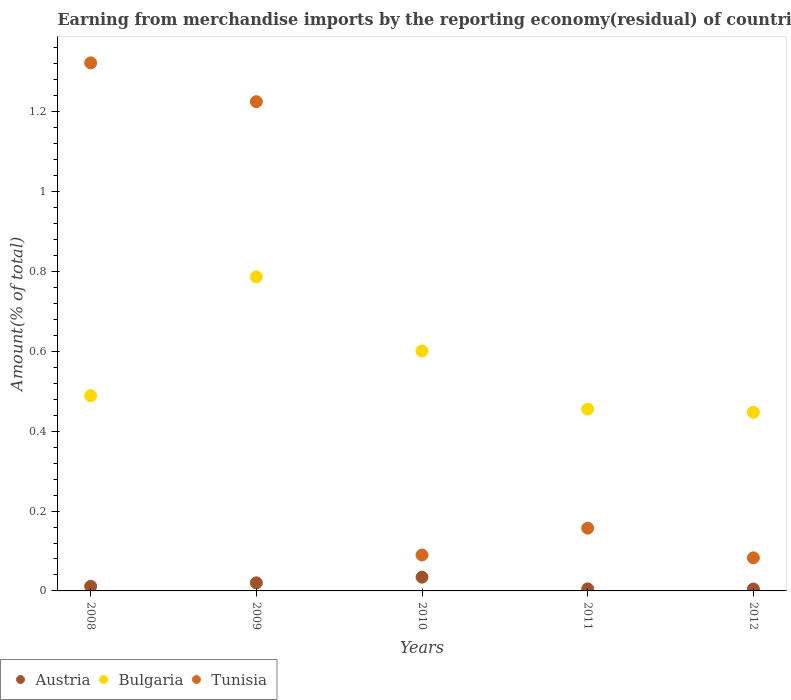Is the number of dotlines equal to the number of legend labels?
Your answer should be compact. Yes. What is the percentage of amount earned from merchandise imports in Bulgaria in 2008?
Offer a terse response. 0.49. Across all years, what is the maximum percentage of amount earned from merchandise imports in Bulgaria?
Offer a terse response. 0.79. Across all years, what is the minimum percentage of amount earned from merchandise imports in Tunisia?
Your response must be concise. 0.08. In which year was the percentage of amount earned from merchandise imports in Austria maximum?
Keep it short and to the point. 2010. In which year was the percentage of amount earned from merchandise imports in Tunisia minimum?
Give a very brief answer. 2012. What is the total percentage of amount earned from merchandise imports in Tunisia in the graph?
Provide a succinct answer. 2.88. What is the difference between the percentage of amount earned from merchandise imports in Tunisia in 2008 and that in 2012?
Your response must be concise. 1.24. What is the difference between the percentage of amount earned from merchandise imports in Bulgaria in 2009 and the percentage of amount earned from merchandise imports in Tunisia in 2008?
Provide a short and direct response. -0.54. What is the average percentage of amount earned from merchandise imports in Bulgaria per year?
Ensure brevity in your answer.  0.56. In the year 2009, what is the difference between the percentage of amount earned from merchandise imports in Tunisia and percentage of amount earned from merchandise imports in Austria?
Provide a short and direct response. 1.21. What is the ratio of the percentage of amount earned from merchandise imports in Tunisia in 2010 to that in 2012?
Give a very brief answer. 1.09. What is the difference between the highest and the second highest percentage of amount earned from merchandise imports in Tunisia?
Your response must be concise. 0.1. What is the difference between the highest and the lowest percentage of amount earned from merchandise imports in Austria?
Your answer should be very brief. 0.03. In how many years, is the percentage of amount earned from merchandise imports in Austria greater than the average percentage of amount earned from merchandise imports in Austria taken over all years?
Your answer should be very brief. 2. Is the sum of the percentage of amount earned from merchandise imports in Bulgaria in 2011 and 2012 greater than the maximum percentage of amount earned from merchandise imports in Austria across all years?
Your response must be concise. Yes. Is it the case that in every year, the sum of the percentage of amount earned from merchandise imports in Tunisia and percentage of amount earned from merchandise imports in Austria  is greater than the percentage of amount earned from merchandise imports in Bulgaria?
Ensure brevity in your answer.  No. Does the percentage of amount earned from merchandise imports in Austria monotonically increase over the years?
Ensure brevity in your answer.  No. Is the percentage of amount earned from merchandise imports in Bulgaria strictly less than the percentage of amount earned from merchandise imports in Austria over the years?
Your answer should be compact. No. How many dotlines are there?
Your answer should be compact. 3. How many years are there in the graph?
Make the answer very short. 5. What is the difference between two consecutive major ticks on the Y-axis?
Offer a very short reply. 0.2. Where does the legend appear in the graph?
Provide a succinct answer. Bottom left. What is the title of the graph?
Keep it short and to the point. Earning from merchandise imports by the reporting economy(residual) of countries. Does "Central Europe" appear as one of the legend labels in the graph?
Offer a very short reply. No. What is the label or title of the Y-axis?
Offer a terse response. Amount(% of total). What is the Amount(% of total) in Austria in 2008?
Your answer should be very brief. 0.01. What is the Amount(% of total) of Bulgaria in 2008?
Make the answer very short. 0.49. What is the Amount(% of total) in Tunisia in 2008?
Your answer should be very brief. 1.32. What is the Amount(% of total) of Austria in 2009?
Your answer should be compact. 0.02. What is the Amount(% of total) in Bulgaria in 2009?
Offer a very short reply. 0.79. What is the Amount(% of total) of Tunisia in 2009?
Make the answer very short. 1.23. What is the Amount(% of total) in Austria in 2010?
Make the answer very short. 0.03. What is the Amount(% of total) of Bulgaria in 2010?
Make the answer very short. 0.6. What is the Amount(% of total) in Tunisia in 2010?
Your answer should be compact. 0.09. What is the Amount(% of total) in Austria in 2011?
Your response must be concise. 0.01. What is the Amount(% of total) of Bulgaria in 2011?
Give a very brief answer. 0.46. What is the Amount(% of total) of Tunisia in 2011?
Provide a succinct answer. 0.16. What is the Amount(% of total) in Austria in 2012?
Your answer should be compact. 0. What is the Amount(% of total) of Bulgaria in 2012?
Ensure brevity in your answer.  0.45. What is the Amount(% of total) of Tunisia in 2012?
Offer a very short reply. 0.08. Across all years, what is the maximum Amount(% of total) in Austria?
Offer a very short reply. 0.03. Across all years, what is the maximum Amount(% of total) in Bulgaria?
Ensure brevity in your answer.  0.79. Across all years, what is the maximum Amount(% of total) in Tunisia?
Offer a terse response. 1.32. Across all years, what is the minimum Amount(% of total) in Austria?
Offer a very short reply. 0. Across all years, what is the minimum Amount(% of total) in Bulgaria?
Offer a terse response. 0.45. Across all years, what is the minimum Amount(% of total) of Tunisia?
Your answer should be very brief. 0.08. What is the total Amount(% of total) of Austria in the graph?
Your response must be concise. 0.08. What is the total Amount(% of total) in Bulgaria in the graph?
Give a very brief answer. 2.78. What is the total Amount(% of total) of Tunisia in the graph?
Offer a very short reply. 2.88. What is the difference between the Amount(% of total) in Austria in 2008 and that in 2009?
Your answer should be very brief. -0.01. What is the difference between the Amount(% of total) in Bulgaria in 2008 and that in 2009?
Offer a very short reply. -0.3. What is the difference between the Amount(% of total) in Tunisia in 2008 and that in 2009?
Your answer should be very brief. 0.1. What is the difference between the Amount(% of total) of Austria in 2008 and that in 2010?
Give a very brief answer. -0.02. What is the difference between the Amount(% of total) in Bulgaria in 2008 and that in 2010?
Give a very brief answer. -0.11. What is the difference between the Amount(% of total) of Tunisia in 2008 and that in 2010?
Ensure brevity in your answer.  1.23. What is the difference between the Amount(% of total) of Austria in 2008 and that in 2011?
Ensure brevity in your answer.  0.01. What is the difference between the Amount(% of total) of Bulgaria in 2008 and that in 2011?
Provide a short and direct response. 0.03. What is the difference between the Amount(% of total) in Tunisia in 2008 and that in 2011?
Your response must be concise. 1.17. What is the difference between the Amount(% of total) in Austria in 2008 and that in 2012?
Offer a terse response. 0.01. What is the difference between the Amount(% of total) in Bulgaria in 2008 and that in 2012?
Offer a very short reply. 0.04. What is the difference between the Amount(% of total) of Tunisia in 2008 and that in 2012?
Make the answer very short. 1.24. What is the difference between the Amount(% of total) in Austria in 2009 and that in 2010?
Offer a terse response. -0.01. What is the difference between the Amount(% of total) in Bulgaria in 2009 and that in 2010?
Keep it short and to the point. 0.19. What is the difference between the Amount(% of total) in Tunisia in 2009 and that in 2010?
Your answer should be very brief. 1.14. What is the difference between the Amount(% of total) of Austria in 2009 and that in 2011?
Offer a very short reply. 0.02. What is the difference between the Amount(% of total) in Bulgaria in 2009 and that in 2011?
Offer a terse response. 0.33. What is the difference between the Amount(% of total) in Tunisia in 2009 and that in 2011?
Keep it short and to the point. 1.07. What is the difference between the Amount(% of total) in Austria in 2009 and that in 2012?
Provide a succinct answer. 0.02. What is the difference between the Amount(% of total) in Bulgaria in 2009 and that in 2012?
Ensure brevity in your answer.  0.34. What is the difference between the Amount(% of total) in Tunisia in 2009 and that in 2012?
Offer a very short reply. 1.14. What is the difference between the Amount(% of total) in Austria in 2010 and that in 2011?
Offer a very short reply. 0.03. What is the difference between the Amount(% of total) in Bulgaria in 2010 and that in 2011?
Give a very brief answer. 0.15. What is the difference between the Amount(% of total) of Tunisia in 2010 and that in 2011?
Give a very brief answer. -0.07. What is the difference between the Amount(% of total) of Austria in 2010 and that in 2012?
Offer a very short reply. 0.03. What is the difference between the Amount(% of total) of Bulgaria in 2010 and that in 2012?
Your response must be concise. 0.15. What is the difference between the Amount(% of total) in Tunisia in 2010 and that in 2012?
Provide a short and direct response. 0.01. What is the difference between the Amount(% of total) of Austria in 2011 and that in 2012?
Offer a very short reply. 0. What is the difference between the Amount(% of total) in Bulgaria in 2011 and that in 2012?
Provide a succinct answer. 0.01. What is the difference between the Amount(% of total) in Tunisia in 2011 and that in 2012?
Provide a short and direct response. 0.07. What is the difference between the Amount(% of total) of Austria in 2008 and the Amount(% of total) of Bulgaria in 2009?
Offer a terse response. -0.78. What is the difference between the Amount(% of total) of Austria in 2008 and the Amount(% of total) of Tunisia in 2009?
Give a very brief answer. -1.21. What is the difference between the Amount(% of total) of Bulgaria in 2008 and the Amount(% of total) of Tunisia in 2009?
Your response must be concise. -0.74. What is the difference between the Amount(% of total) in Austria in 2008 and the Amount(% of total) in Bulgaria in 2010?
Offer a very short reply. -0.59. What is the difference between the Amount(% of total) in Austria in 2008 and the Amount(% of total) in Tunisia in 2010?
Offer a terse response. -0.08. What is the difference between the Amount(% of total) of Bulgaria in 2008 and the Amount(% of total) of Tunisia in 2010?
Your response must be concise. 0.4. What is the difference between the Amount(% of total) in Austria in 2008 and the Amount(% of total) in Bulgaria in 2011?
Your answer should be very brief. -0.44. What is the difference between the Amount(% of total) in Austria in 2008 and the Amount(% of total) in Tunisia in 2011?
Ensure brevity in your answer.  -0.15. What is the difference between the Amount(% of total) of Bulgaria in 2008 and the Amount(% of total) of Tunisia in 2011?
Offer a very short reply. 0.33. What is the difference between the Amount(% of total) in Austria in 2008 and the Amount(% of total) in Bulgaria in 2012?
Make the answer very short. -0.44. What is the difference between the Amount(% of total) in Austria in 2008 and the Amount(% of total) in Tunisia in 2012?
Your response must be concise. -0.07. What is the difference between the Amount(% of total) in Bulgaria in 2008 and the Amount(% of total) in Tunisia in 2012?
Your response must be concise. 0.41. What is the difference between the Amount(% of total) in Austria in 2009 and the Amount(% of total) in Bulgaria in 2010?
Ensure brevity in your answer.  -0.58. What is the difference between the Amount(% of total) in Austria in 2009 and the Amount(% of total) in Tunisia in 2010?
Ensure brevity in your answer.  -0.07. What is the difference between the Amount(% of total) in Bulgaria in 2009 and the Amount(% of total) in Tunisia in 2010?
Offer a terse response. 0.7. What is the difference between the Amount(% of total) of Austria in 2009 and the Amount(% of total) of Bulgaria in 2011?
Your answer should be very brief. -0.43. What is the difference between the Amount(% of total) in Austria in 2009 and the Amount(% of total) in Tunisia in 2011?
Offer a terse response. -0.14. What is the difference between the Amount(% of total) of Bulgaria in 2009 and the Amount(% of total) of Tunisia in 2011?
Make the answer very short. 0.63. What is the difference between the Amount(% of total) in Austria in 2009 and the Amount(% of total) in Bulgaria in 2012?
Your answer should be compact. -0.43. What is the difference between the Amount(% of total) in Austria in 2009 and the Amount(% of total) in Tunisia in 2012?
Give a very brief answer. -0.06. What is the difference between the Amount(% of total) of Bulgaria in 2009 and the Amount(% of total) of Tunisia in 2012?
Provide a succinct answer. 0.7. What is the difference between the Amount(% of total) in Austria in 2010 and the Amount(% of total) in Bulgaria in 2011?
Offer a terse response. -0.42. What is the difference between the Amount(% of total) of Austria in 2010 and the Amount(% of total) of Tunisia in 2011?
Keep it short and to the point. -0.12. What is the difference between the Amount(% of total) in Bulgaria in 2010 and the Amount(% of total) in Tunisia in 2011?
Your answer should be compact. 0.44. What is the difference between the Amount(% of total) in Austria in 2010 and the Amount(% of total) in Bulgaria in 2012?
Give a very brief answer. -0.41. What is the difference between the Amount(% of total) in Austria in 2010 and the Amount(% of total) in Tunisia in 2012?
Ensure brevity in your answer.  -0.05. What is the difference between the Amount(% of total) of Bulgaria in 2010 and the Amount(% of total) of Tunisia in 2012?
Provide a short and direct response. 0.52. What is the difference between the Amount(% of total) in Austria in 2011 and the Amount(% of total) in Bulgaria in 2012?
Your answer should be very brief. -0.44. What is the difference between the Amount(% of total) in Austria in 2011 and the Amount(% of total) in Tunisia in 2012?
Ensure brevity in your answer.  -0.08. What is the difference between the Amount(% of total) of Bulgaria in 2011 and the Amount(% of total) of Tunisia in 2012?
Make the answer very short. 0.37. What is the average Amount(% of total) of Austria per year?
Your answer should be compact. 0.02. What is the average Amount(% of total) of Bulgaria per year?
Keep it short and to the point. 0.56. What is the average Amount(% of total) of Tunisia per year?
Give a very brief answer. 0.58. In the year 2008, what is the difference between the Amount(% of total) in Austria and Amount(% of total) in Bulgaria?
Ensure brevity in your answer.  -0.48. In the year 2008, what is the difference between the Amount(% of total) in Austria and Amount(% of total) in Tunisia?
Provide a succinct answer. -1.31. In the year 2008, what is the difference between the Amount(% of total) in Bulgaria and Amount(% of total) in Tunisia?
Your response must be concise. -0.83. In the year 2009, what is the difference between the Amount(% of total) in Austria and Amount(% of total) in Bulgaria?
Keep it short and to the point. -0.77. In the year 2009, what is the difference between the Amount(% of total) of Austria and Amount(% of total) of Tunisia?
Your response must be concise. -1.21. In the year 2009, what is the difference between the Amount(% of total) in Bulgaria and Amount(% of total) in Tunisia?
Your response must be concise. -0.44. In the year 2010, what is the difference between the Amount(% of total) in Austria and Amount(% of total) in Bulgaria?
Your answer should be very brief. -0.57. In the year 2010, what is the difference between the Amount(% of total) in Austria and Amount(% of total) in Tunisia?
Ensure brevity in your answer.  -0.06. In the year 2010, what is the difference between the Amount(% of total) in Bulgaria and Amount(% of total) in Tunisia?
Provide a succinct answer. 0.51. In the year 2011, what is the difference between the Amount(% of total) in Austria and Amount(% of total) in Bulgaria?
Give a very brief answer. -0.45. In the year 2011, what is the difference between the Amount(% of total) of Austria and Amount(% of total) of Tunisia?
Give a very brief answer. -0.15. In the year 2011, what is the difference between the Amount(% of total) in Bulgaria and Amount(% of total) in Tunisia?
Offer a very short reply. 0.3. In the year 2012, what is the difference between the Amount(% of total) of Austria and Amount(% of total) of Bulgaria?
Offer a terse response. -0.44. In the year 2012, what is the difference between the Amount(% of total) in Austria and Amount(% of total) in Tunisia?
Your answer should be very brief. -0.08. In the year 2012, what is the difference between the Amount(% of total) of Bulgaria and Amount(% of total) of Tunisia?
Offer a very short reply. 0.36. What is the ratio of the Amount(% of total) in Austria in 2008 to that in 2009?
Give a very brief answer. 0.57. What is the ratio of the Amount(% of total) of Bulgaria in 2008 to that in 2009?
Provide a succinct answer. 0.62. What is the ratio of the Amount(% of total) in Tunisia in 2008 to that in 2009?
Offer a very short reply. 1.08. What is the ratio of the Amount(% of total) of Austria in 2008 to that in 2010?
Ensure brevity in your answer.  0.34. What is the ratio of the Amount(% of total) in Bulgaria in 2008 to that in 2010?
Your response must be concise. 0.81. What is the ratio of the Amount(% of total) in Tunisia in 2008 to that in 2010?
Ensure brevity in your answer.  14.71. What is the ratio of the Amount(% of total) of Austria in 2008 to that in 2011?
Make the answer very short. 2.24. What is the ratio of the Amount(% of total) of Bulgaria in 2008 to that in 2011?
Offer a terse response. 1.07. What is the ratio of the Amount(% of total) in Tunisia in 2008 to that in 2011?
Your answer should be very brief. 8.41. What is the ratio of the Amount(% of total) of Austria in 2008 to that in 2012?
Provide a short and direct response. 2.4. What is the ratio of the Amount(% of total) in Bulgaria in 2008 to that in 2012?
Provide a short and direct response. 1.09. What is the ratio of the Amount(% of total) of Tunisia in 2008 to that in 2012?
Your answer should be compact. 15.97. What is the ratio of the Amount(% of total) of Austria in 2009 to that in 2010?
Ensure brevity in your answer.  0.59. What is the ratio of the Amount(% of total) of Bulgaria in 2009 to that in 2010?
Ensure brevity in your answer.  1.31. What is the ratio of the Amount(% of total) in Tunisia in 2009 to that in 2010?
Your answer should be compact. 13.63. What is the ratio of the Amount(% of total) of Austria in 2009 to that in 2011?
Your answer should be very brief. 3.93. What is the ratio of the Amount(% of total) in Bulgaria in 2009 to that in 2011?
Keep it short and to the point. 1.73. What is the ratio of the Amount(% of total) in Tunisia in 2009 to that in 2011?
Your answer should be compact. 7.79. What is the ratio of the Amount(% of total) in Austria in 2009 to that in 2012?
Offer a terse response. 4.22. What is the ratio of the Amount(% of total) of Bulgaria in 2009 to that in 2012?
Ensure brevity in your answer.  1.76. What is the ratio of the Amount(% of total) in Tunisia in 2009 to that in 2012?
Your answer should be very brief. 14.8. What is the ratio of the Amount(% of total) in Austria in 2010 to that in 2011?
Keep it short and to the point. 6.69. What is the ratio of the Amount(% of total) in Bulgaria in 2010 to that in 2011?
Ensure brevity in your answer.  1.32. What is the ratio of the Amount(% of total) of Tunisia in 2010 to that in 2011?
Offer a very short reply. 0.57. What is the ratio of the Amount(% of total) of Austria in 2010 to that in 2012?
Offer a terse response. 7.17. What is the ratio of the Amount(% of total) in Bulgaria in 2010 to that in 2012?
Your response must be concise. 1.34. What is the ratio of the Amount(% of total) in Tunisia in 2010 to that in 2012?
Keep it short and to the point. 1.09. What is the ratio of the Amount(% of total) in Austria in 2011 to that in 2012?
Provide a short and direct response. 1.07. What is the ratio of the Amount(% of total) in Bulgaria in 2011 to that in 2012?
Keep it short and to the point. 1.02. What is the ratio of the Amount(% of total) in Tunisia in 2011 to that in 2012?
Keep it short and to the point. 1.9. What is the difference between the highest and the second highest Amount(% of total) in Austria?
Your answer should be compact. 0.01. What is the difference between the highest and the second highest Amount(% of total) in Bulgaria?
Ensure brevity in your answer.  0.19. What is the difference between the highest and the second highest Amount(% of total) of Tunisia?
Give a very brief answer. 0.1. What is the difference between the highest and the lowest Amount(% of total) of Austria?
Provide a succinct answer. 0.03. What is the difference between the highest and the lowest Amount(% of total) in Bulgaria?
Ensure brevity in your answer.  0.34. What is the difference between the highest and the lowest Amount(% of total) of Tunisia?
Make the answer very short. 1.24. 